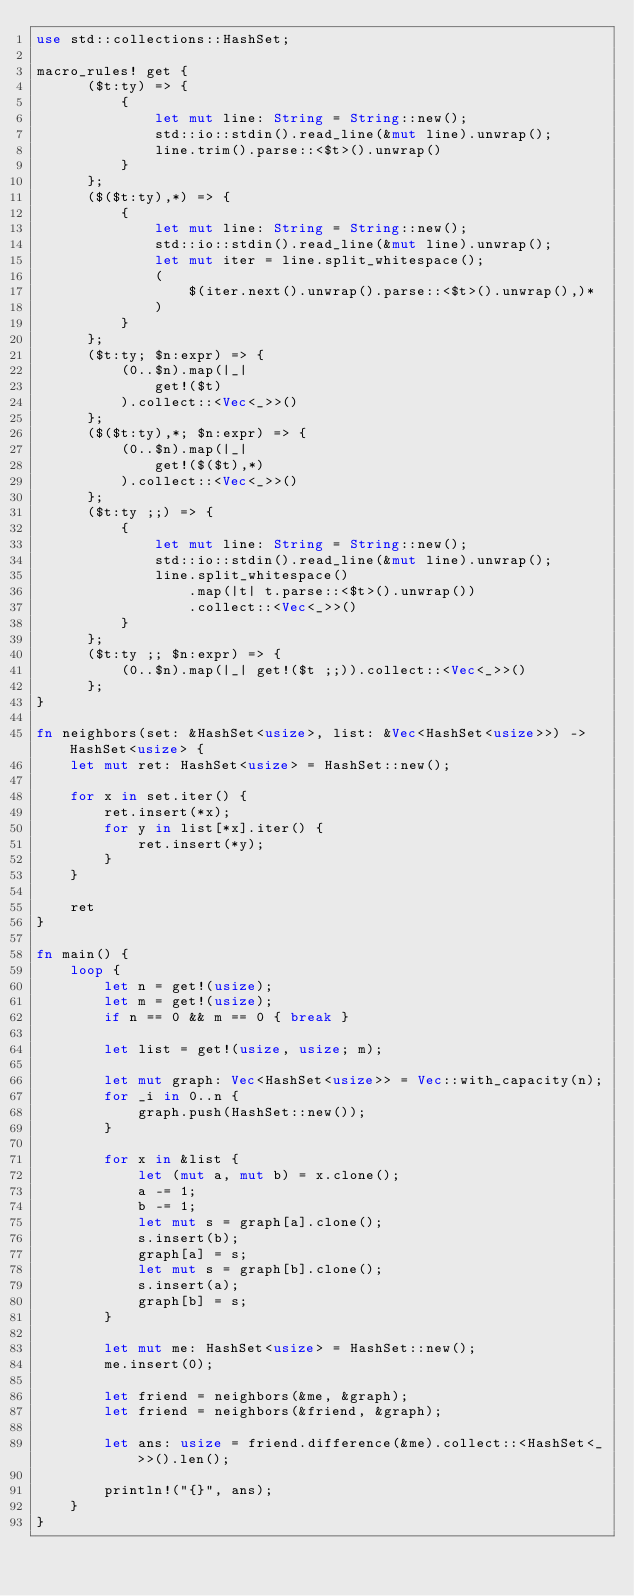Convert code to text. <code><loc_0><loc_0><loc_500><loc_500><_Rust_>use std::collections::HashSet;

macro_rules! get {
      ($t:ty) => {
          {
              let mut line: String = String::new();
              std::io::stdin().read_line(&mut line).unwrap();
              line.trim().parse::<$t>().unwrap()
          }
      };
      ($($t:ty),*) => {
          {
              let mut line: String = String::new();
              std::io::stdin().read_line(&mut line).unwrap();
              let mut iter = line.split_whitespace();
              (
                  $(iter.next().unwrap().parse::<$t>().unwrap(),)*
              )
          }
      };
      ($t:ty; $n:expr) => {
          (0..$n).map(|_|
              get!($t)
          ).collect::<Vec<_>>()
      };
      ($($t:ty),*; $n:expr) => {
          (0..$n).map(|_|
              get!($($t),*)
          ).collect::<Vec<_>>()
      };
      ($t:ty ;;) => {
          {
              let mut line: String = String::new();
              std::io::stdin().read_line(&mut line).unwrap();
              line.split_whitespace()
                  .map(|t| t.parse::<$t>().unwrap())
                  .collect::<Vec<_>>()
          }
      };
      ($t:ty ;; $n:expr) => {
          (0..$n).map(|_| get!($t ;;)).collect::<Vec<_>>()
      };
}

fn neighbors(set: &HashSet<usize>, list: &Vec<HashSet<usize>>) -> HashSet<usize> {
    let mut ret: HashSet<usize> = HashSet::new();

    for x in set.iter() {
        ret.insert(*x);
        for y in list[*x].iter() {
            ret.insert(*y);
        }
    }

    ret
}

fn main() {
    loop {
        let n = get!(usize);
        let m = get!(usize);
        if n == 0 && m == 0 { break }

        let list = get!(usize, usize; m);

        let mut graph: Vec<HashSet<usize>> = Vec::with_capacity(n);
        for _i in 0..n {
            graph.push(HashSet::new());
        }

        for x in &list {
            let (mut a, mut b) = x.clone();
            a -= 1;
            b -= 1;
            let mut s = graph[a].clone();
            s.insert(b);
            graph[a] = s;
            let mut s = graph[b].clone();
            s.insert(a);
            graph[b] = s;
        }

        let mut me: HashSet<usize> = HashSet::new();
        me.insert(0);

        let friend = neighbors(&me, &graph);
        let friend = neighbors(&friend, &graph);

        let ans: usize = friend.difference(&me).collect::<HashSet<_>>().len();

        println!("{}", ans);
    }
}

</code> 